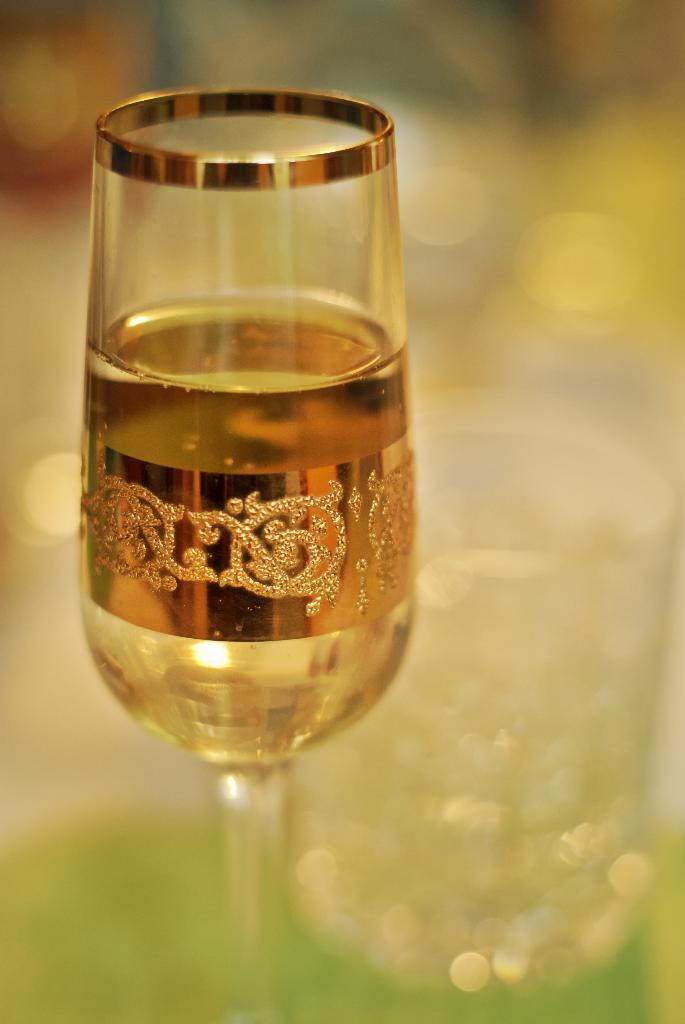What object is present in the image that can hold a liquid? There is a glass in the image that can hold a liquid. What is inside the glass in the image? The glass contains a drink. Can you describe the background of the image? The background of the image is blurred. What type of toy can be seen in the image? There is no toy present in the image. How does the lawyer use the glass in the image? There is no lawyer present in the image, and therefore no one is using the glass for any specific purpose. 